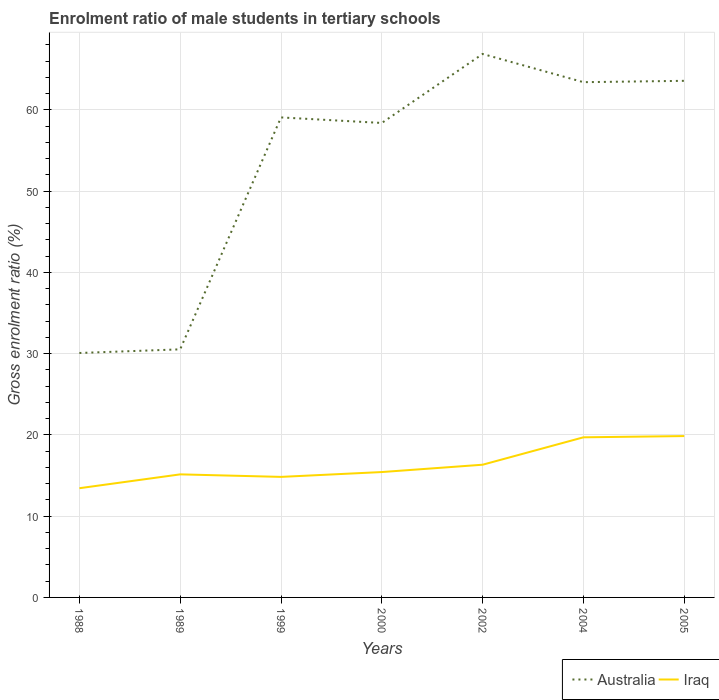Does the line corresponding to Australia intersect with the line corresponding to Iraq?
Give a very brief answer. No. Is the number of lines equal to the number of legend labels?
Make the answer very short. Yes. Across all years, what is the maximum enrolment ratio of male students in tertiary schools in Iraq?
Ensure brevity in your answer.  13.44. What is the total enrolment ratio of male students in tertiary schools in Iraq in the graph?
Offer a very short reply. -1.19. What is the difference between the highest and the second highest enrolment ratio of male students in tertiary schools in Australia?
Ensure brevity in your answer.  36.8. How many lines are there?
Give a very brief answer. 2. How many years are there in the graph?
Provide a succinct answer. 7. Does the graph contain any zero values?
Your answer should be very brief. No. What is the title of the graph?
Your response must be concise. Enrolment ratio of male students in tertiary schools. What is the label or title of the X-axis?
Offer a very short reply. Years. What is the Gross enrolment ratio (%) in Australia in 1988?
Your answer should be very brief. 30.08. What is the Gross enrolment ratio (%) in Iraq in 1988?
Your answer should be very brief. 13.44. What is the Gross enrolment ratio (%) in Australia in 1989?
Your response must be concise. 30.53. What is the Gross enrolment ratio (%) of Iraq in 1989?
Your answer should be very brief. 15.15. What is the Gross enrolment ratio (%) in Australia in 1999?
Your response must be concise. 59.08. What is the Gross enrolment ratio (%) in Iraq in 1999?
Provide a succinct answer. 14.83. What is the Gross enrolment ratio (%) of Australia in 2000?
Your answer should be compact. 58.39. What is the Gross enrolment ratio (%) of Iraq in 2000?
Provide a succinct answer. 15.43. What is the Gross enrolment ratio (%) in Australia in 2002?
Provide a succinct answer. 66.89. What is the Gross enrolment ratio (%) in Iraq in 2002?
Provide a succinct answer. 16.33. What is the Gross enrolment ratio (%) in Australia in 2004?
Your response must be concise. 63.41. What is the Gross enrolment ratio (%) in Iraq in 2004?
Make the answer very short. 19.71. What is the Gross enrolment ratio (%) in Australia in 2005?
Give a very brief answer. 63.58. What is the Gross enrolment ratio (%) in Iraq in 2005?
Give a very brief answer. 19.86. Across all years, what is the maximum Gross enrolment ratio (%) of Australia?
Provide a short and direct response. 66.89. Across all years, what is the maximum Gross enrolment ratio (%) in Iraq?
Offer a terse response. 19.86. Across all years, what is the minimum Gross enrolment ratio (%) of Australia?
Keep it short and to the point. 30.08. Across all years, what is the minimum Gross enrolment ratio (%) in Iraq?
Your response must be concise. 13.44. What is the total Gross enrolment ratio (%) of Australia in the graph?
Offer a terse response. 371.97. What is the total Gross enrolment ratio (%) of Iraq in the graph?
Offer a terse response. 114.75. What is the difference between the Gross enrolment ratio (%) in Australia in 1988 and that in 1989?
Your response must be concise. -0.45. What is the difference between the Gross enrolment ratio (%) in Iraq in 1988 and that in 1989?
Offer a terse response. -1.7. What is the difference between the Gross enrolment ratio (%) in Australia in 1988 and that in 1999?
Your answer should be compact. -28.99. What is the difference between the Gross enrolment ratio (%) in Iraq in 1988 and that in 1999?
Your response must be concise. -1.39. What is the difference between the Gross enrolment ratio (%) of Australia in 1988 and that in 2000?
Your response must be concise. -28.31. What is the difference between the Gross enrolment ratio (%) of Iraq in 1988 and that in 2000?
Keep it short and to the point. -1.99. What is the difference between the Gross enrolment ratio (%) of Australia in 1988 and that in 2002?
Keep it short and to the point. -36.8. What is the difference between the Gross enrolment ratio (%) of Iraq in 1988 and that in 2002?
Make the answer very short. -2.89. What is the difference between the Gross enrolment ratio (%) of Australia in 1988 and that in 2004?
Your answer should be very brief. -33.33. What is the difference between the Gross enrolment ratio (%) in Iraq in 1988 and that in 2004?
Provide a short and direct response. -6.26. What is the difference between the Gross enrolment ratio (%) of Australia in 1988 and that in 2005?
Your answer should be very brief. -33.5. What is the difference between the Gross enrolment ratio (%) of Iraq in 1988 and that in 2005?
Offer a terse response. -6.42. What is the difference between the Gross enrolment ratio (%) of Australia in 1989 and that in 1999?
Your answer should be very brief. -28.54. What is the difference between the Gross enrolment ratio (%) of Iraq in 1989 and that in 1999?
Ensure brevity in your answer.  0.31. What is the difference between the Gross enrolment ratio (%) in Australia in 1989 and that in 2000?
Your response must be concise. -27.86. What is the difference between the Gross enrolment ratio (%) in Iraq in 1989 and that in 2000?
Make the answer very short. -0.28. What is the difference between the Gross enrolment ratio (%) of Australia in 1989 and that in 2002?
Your answer should be compact. -36.35. What is the difference between the Gross enrolment ratio (%) in Iraq in 1989 and that in 2002?
Provide a succinct answer. -1.19. What is the difference between the Gross enrolment ratio (%) in Australia in 1989 and that in 2004?
Make the answer very short. -32.88. What is the difference between the Gross enrolment ratio (%) of Iraq in 1989 and that in 2004?
Provide a short and direct response. -4.56. What is the difference between the Gross enrolment ratio (%) in Australia in 1989 and that in 2005?
Your answer should be compact. -33.05. What is the difference between the Gross enrolment ratio (%) of Iraq in 1989 and that in 2005?
Provide a succinct answer. -4.71. What is the difference between the Gross enrolment ratio (%) of Australia in 1999 and that in 2000?
Provide a succinct answer. 0.68. What is the difference between the Gross enrolment ratio (%) of Iraq in 1999 and that in 2000?
Your response must be concise. -0.6. What is the difference between the Gross enrolment ratio (%) of Australia in 1999 and that in 2002?
Ensure brevity in your answer.  -7.81. What is the difference between the Gross enrolment ratio (%) of Iraq in 1999 and that in 2002?
Your answer should be compact. -1.5. What is the difference between the Gross enrolment ratio (%) of Australia in 1999 and that in 2004?
Your response must be concise. -4.34. What is the difference between the Gross enrolment ratio (%) in Iraq in 1999 and that in 2004?
Make the answer very short. -4.87. What is the difference between the Gross enrolment ratio (%) in Australia in 1999 and that in 2005?
Keep it short and to the point. -4.5. What is the difference between the Gross enrolment ratio (%) in Iraq in 1999 and that in 2005?
Keep it short and to the point. -5.03. What is the difference between the Gross enrolment ratio (%) of Australia in 2000 and that in 2002?
Your answer should be compact. -8.49. What is the difference between the Gross enrolment ratio (%) of Iraq in 2000 and that in 2002?
Your answer should be compact. -0.9. What is the difference between the Gross enrolment ratio (%) in Australia in 2000 and that in 2004?
Your response must be concise. -5.02. What is the difference between the Gross enrolment ratio (%) of Iraq in 2000 and that in 2004?
Make the answer very short. -4.28. What is the difference between the Gross enrolment ratio (%) in Australia in 2000 and that in 2005?
Ensure brevity in your answer.  -5.19. What is the difference between the Gross enrolment ratio (%) of Iraq in 2000 and that in 2005?
Make the answer very short. -4.43. What is the difference between the Gross enrolment ratio (%) of Australia in 2002 and that in 2004?
Ensure brevity in your answer.  3.47. What is the difference between the Gross enrolment ratio (%) of Iraq in 2002 and that in 2004?
Your answer should be very brief. -3.37. What is the difference between the Gross enrolment ratio (%) in Australia in 2002 and that in 2005?
Your answer should be very brief. 3.31. What is the difference between the Gross enrolment ratio (%) in Iraq in 2002 and that in 2005?
Give a very brief answer. -3.53. What is the difference between the Gross enrolment ratio (%) of Australia in 2004 and that in 2005?
Your response must be concise. -0.17. What is the difference between the Gross enrolment ratio (%) in Iraq in 2004 and that in 2005?
Your answer should be very brief. -0.15. What is the difference between the Gross enrolment ratio (%) of Australia in 1988 and the Gross enrolment ratio (%) of Iraq in 1989?
Offer a very short reply. 14.94. What is the difference between the Gross enrolment ratio (%) in Australia in 1988 and the Gross enrolment ratio (%) in Iraq in 1999?
Provide a succinct answer. 15.25. What is the difference between the Gross enrolment ratio (%) of Australia in 1988 and the Gross enrolment ratio (%) of Iraq in 2000?
Offer a very short reply. 14.65. What is the difference between the Gross enrolment ratio (%) in Australia in 1988 and the Gross enrolment ratio (%) in Iraq in 2002?
Your answer should be very brief. 13.75. What is the difference between the Gross enrolment ratio (%) of Australia in 1988 and the Gross enrolment ratio (%) of Iraq in 2004?
Ensure brevity in your answer.  10.38. What is the difference between the Gross enrolment ratio (%) of Australia in 1988 and the Gross enrolment ratio (%) of Iraq in 2005?
Make the answer very short. 10.22. What is the difference between the Gross enrolment ratio (%) in Australia in 1989 and the Gross enrolment ratio (%) in Iraq in 1999?
Give a very brief answer. 15.7. What is the difference between the Gross enrolment ratio (%) of Australia in 1989 and the Gross enrolment ratio (%) of Iraq in 2000?
Your response must be concise. 15.1. What is the difference between the Gross enrolment ratio (%) in Australia in 1989 and the Gross enrolment ratio (%) in Iraq in 2002?
Make the answer very short. 14.2. What is the difference between the Gross enrolment ratio (%) of Australia in 1989 and the Gross enrolment ratio (%) of Iraq in 2004?
Provide a succinct answer. 10.83. What is the difference between the Gross enrolment ratio (%) of Australia in 1989 and the Gross enrolment ratio (%) of Iraq in 2005?
Give a very brief answer. 10.67. What is the difference between the Gross enrolment ratio (%) in Australia in 1999 and the Gross enrolment ratio (%) in Iraq in 2000?
Your answer should be compact. 43.65. What is the difference between the Gross enrolment ratio (%) of Australia in 1999 and the Gross enrolment ratio (%) of Iraq in 2002?
Ensure brevity in your answer.  42.74. What is the difference between the Gross enrolment ratio (%) of Australia in 1999 and the Gross enrolment ratio (%) of Iraq in 2004?
Make the answer very short. 39.37. What is the difference between the Gross enrolment ratio (%) of Australia in 1999 and the Gross enrolment ratio (%) of Iraq in 2005?
Offer a terse response. 39.22. What is the difference between the Gross enrolment ratio (%) in Australia in 2000 and the Gross enrolment ratio (%) in Iraq in 2002?
Your answer should be very brief. 42.06. What is the difference between the Gross enrolment ratio (%) in Australia in 2000 and the Gross enrolment ratio (%) in Iraq in 2004?
Offer a terse response. 38.69. What is the difference between the Gross enrolment ratio (%) in Australia in 2000 and the Gross enrolment ratio (%) in Iraq in 2005?
Make the answer very short. 38.53. What is the difference between the Gross enrolment ratio (%) of Australia in 2002 and the Gross enrolment ratio (%) of Iraq in 2004?
Your answer should be very brief. 47.18. What is the difference between the Gross enrolment ratio (%) in Australia in 2002 and the Gross enrolment ratio (%) in Iraq in 2005?
Ensure brevity in your answer.  47.03. What is the difference between the Gross enrolment ratio (%) in Australia in 2004 and the Gross enrolment ratio (%) in Iraq in 2005?
Ensure brevity in your answer.  43.55. What is the average Gross enrolment ratio (%) in Australia per year?
Keep it short and to the point. 53.14. What is the average Gross enrolment ratio (%) of Iraq per year?
Make the answer very short. 16.39. In the year 1988, what is the difference between the Gross enrolment ratio (%) in Australia and Gross enrolment ratio (%) in Iraq?
Ensure brevity in your answer.  16.64. In the year 1989, what is the difference between the Gross enrolment ratio (%) in Australia and Gross enrolment ratio (%) in Iraq?
Provide a succinct answer. 15.39. In the year 1999, what is the difference between the Gross enrolment ratio (%) of Australia and Gross enrolment ratio (%) of Iraq?
Provide a short and direct response. 44.24. In the year 2000, what is the difference between the Gross enrolment ratio (%) of Australia and Gross enrolment ratio (%) of Iraq?
Your response must be concise. 42.96. In the year 2002, what is the difference between the Gross enrolment ratio (%) of Australia and Gross enrolment ratio (%) of Iraq?
Offer a terse response. 50.55. In the year 2004, what is the difference between the Gross enrolment ratio (%) in Australia and Gross enrolment ratio (%) in Iraq?
Offer a terse response. 43.71. In the year 2005, what is the difference between the Gross enrolment ratio (%) in Australia and Gross enrolment ratio (%) in Iraq?
Offer a terse response. 43.72. What is the ratio of the Gross enrolment ratio (%) in Iraq in 1988 to that in 1989?
Offer a very short reply. 0.89. What is the ratio of the Gross enrolment ratio (%) in Australia in 1988 to that in 1999?
Keep it short and to the point. 0.51. What is the ratio of the Gross enrolment ratio (%) of Iraq in 1988 to that in 1999?
Your answer should be compact. 0.91. What is the ratio of the Gross enrolment ratio (%) of Australia in 1988 to that in 2000?
Make the answer very short. 0.52. What is the ratio of the Gross enrolment ratio (%) in Iraq in 1988 to that in 2000?
Give a very brief answer. 0.87. What is the ratio of the Gross enrolment ratio (%) in Australia in 1988 to that in 2002?
Provide a succinct answer. 0.45. What is the ratio of the Gross enrolment ratio (%) in Iraq in 1988 to that in 2002?
Ensure brevity in your answer.  0.82. What is the ratio of the Gross enrolment ratio (%) of Australia in 1988 to that in 2004?
Ensure brevity in your answer.  0.47. What is the ratio of the Gross enrolment ratio (%) of Iraq in 1988 to that in 2004?
Your answer should be compact. 0.68. What is the ratio of the Gross enrolment ratio (%) in Australia in 1988 to that in 2005?
Offer a very short reply. 0.47. What is the ratio of the Gross enrolment ratio (%) in Iraq in 1988 to that in 2005?
Offer a very short reply. 0.68. What is the ratio of the Gross enrolment ratio (%) of Australia in 1989 to that in 1999?
Make the answer very short. 0.52. What is the ratio of the Gross enrolment ratio (%) of Iraq in 1989 to that in 1999?
Provide a succinct answer. 1.02. What is the ratio of the Gross enrolment ratio (%) of Australia in 1989 to that in 2000?
Your answer should be compact. 0.52. What is the ratio of the Gross enrolment ratio (%) of Iraq in 1989 to that in 2000?
Your answer should be very brief. 0.98. What is the ratio of the Gross enrolment ratio (%) in Australia in 1989 to that in 2002?
Ensure brevity in your answer.  0.46. What is the ratio of the Gross enrolment ratio (%) in Iraq in 1989 to that in 2002?
Your answer should be compact. 0.93. What is the ratio of the Gross enrolment ratio (%) of Australia in 1989 to that in 2004?
Make the answer very short. 0.48. What is the ratio of the Gross enrolment ratio (%) of Iraq in 1989 to that in 2004?
Your response must be concise. 0.77. What is the ratio of the Gross enrolment ratio (%) in Australia in 1989 to that in 2005?
Give a very brief answer. 0.48. What is the ratio of the Gross enrolment ratio (%) in Iraq in 1989 to that in 2005?
Make the answer very short. 0.76. What is the ratio of the Gross enrolment ratio (%) in Australia in 1999 to that in 2000?
Provide a succinct answer. 1.01. What is the ratio of the Gross enrolment ratio (%) of Iraq in 1999 to that in 2000?
Your response must be concise. 0.96. What is the ratio of the Gross enrolment ratio (%) of Australia in 1999 to that in 2002?
Give a very brief answer. 0.88. What is the ratio of the Gross enrolment ratio (%) in Iraq in 1999 to that in 2002?
Give a very brief answer. 0.91. What is the ratio of the Gross enrolment ratio (%) in Australia in 1999 to that in 2004?
Make the answer very short. 0.93. What is the ratio of the Gross enrolment ratio (%) of Iraq in 1999 to that in 2004?
Ensure brevity in your answer.  0.75. What is the ratio of the Gross enrolment ratio (%) in Australia in 1999 to that in 2005?
Make the answer very short. 0.93. What is the ratio of the Gross enrolment ratio (%) in Iraq in 1999 to that in 2005?
Offer a very short reply. 0.75. What is the ratio of the Gross enrolment ratio (%) of Australia in 2000 to that in 2002?
Offer a terse response. 0.87. What is the ratio of the Gross enrolment ratio (%) in Iraq in 2000 to that in 2002?
Give a very brief answer. 0.94. What is the ratio of the Gross enrolment ratio (%) in Australia in 2000 to that in 2004?
Offer a very short reply. 0.92. What is the ratio of the Gross enrolment ratio (%) in Iraq in 2000 to that in 2004?
Make the answer very short. 0.78. What is the ratio of the Gross enrolment ratio (%) in Australia in 2000 to that in 2005?
Your response must be concise. 0.92. What is the ratio of the Gross enrolment ratio (%) of Iraq in 2000 to that in 2005?
Offer a terse response. 0.78. What is the ratio of the Gross enrolment ratio (%) of Australia in 2002 to that in 2004?
Provide a short and direct response. 1.05. What is the ratio of the Gross enrolment ratio (%) in Iraq in 2002 to that in 2004?
Ensure brevity in your answer.  0.83. What is the ratio of the Gross enrolment ratio (%) of Australia in 2002 to that in 2005?
Make the answer very short. 1.05. What is the ratio of the Gross enrolment ratio (%) of Iraq in 2002 to that in 2005?
Give a very brief answer. 0.82. What is the difference between the highest and the second highest Gross enrolment ratio (%) of Australia?
Make the answer very short. 3.31. What is the difference between the highest and the second highest Gross enrolment ratio (%) of Iraq?
Your response must be concise. 0.15. What is the difference between the highest and the lowest Gross enrolment ratio (%) of Australia?
Provide a succinct answer. 36.8. What is the difference between the highest and the lowest Gross enrolment ratio (%) in Iraq?
Your answer should be very brief. 6.42. 